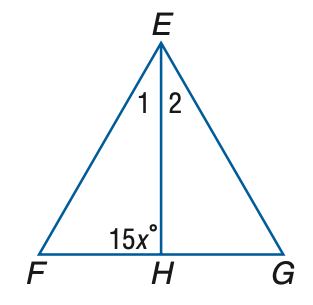Question: \triangle E F G is equilateral, and E H bisects \angle E. Find x.
Choices:
A. 5
B. 6
C. 7
D. 8
Answer with the letter. Answer: B 